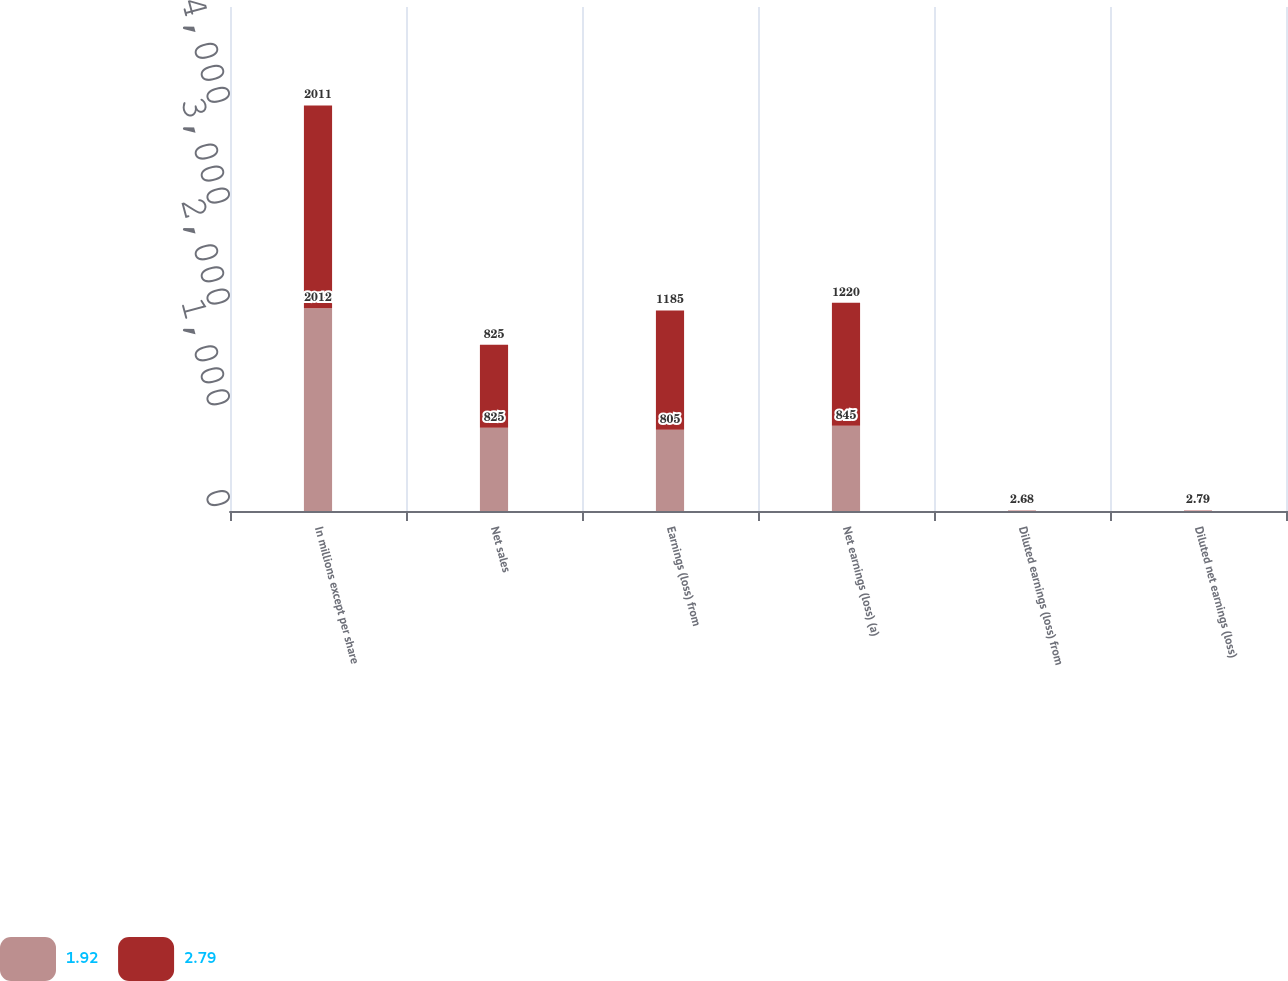<chart> <loc_0><loc_0><loc_500><loc_500><stacked_bar_chart><ecel><fcel>In millions except per share<fcel>Net sales<fcel>Earnings (loss) from<fcel>Net earnings (loss) (a)<fcel>Diluted earnings (loss) from<fcel>Diluted net earnings (loss)<nl><fcel>1.92<fcel>2012<fcel>825<fcel>805<fcel>845<fcel>1.82<fcel>1.92<nl><fcel>2.79<fcel>2011<fcel>825<fcel>1185<fcel>1220<fcel>2.68<fcel>2.79<nl></chart> 